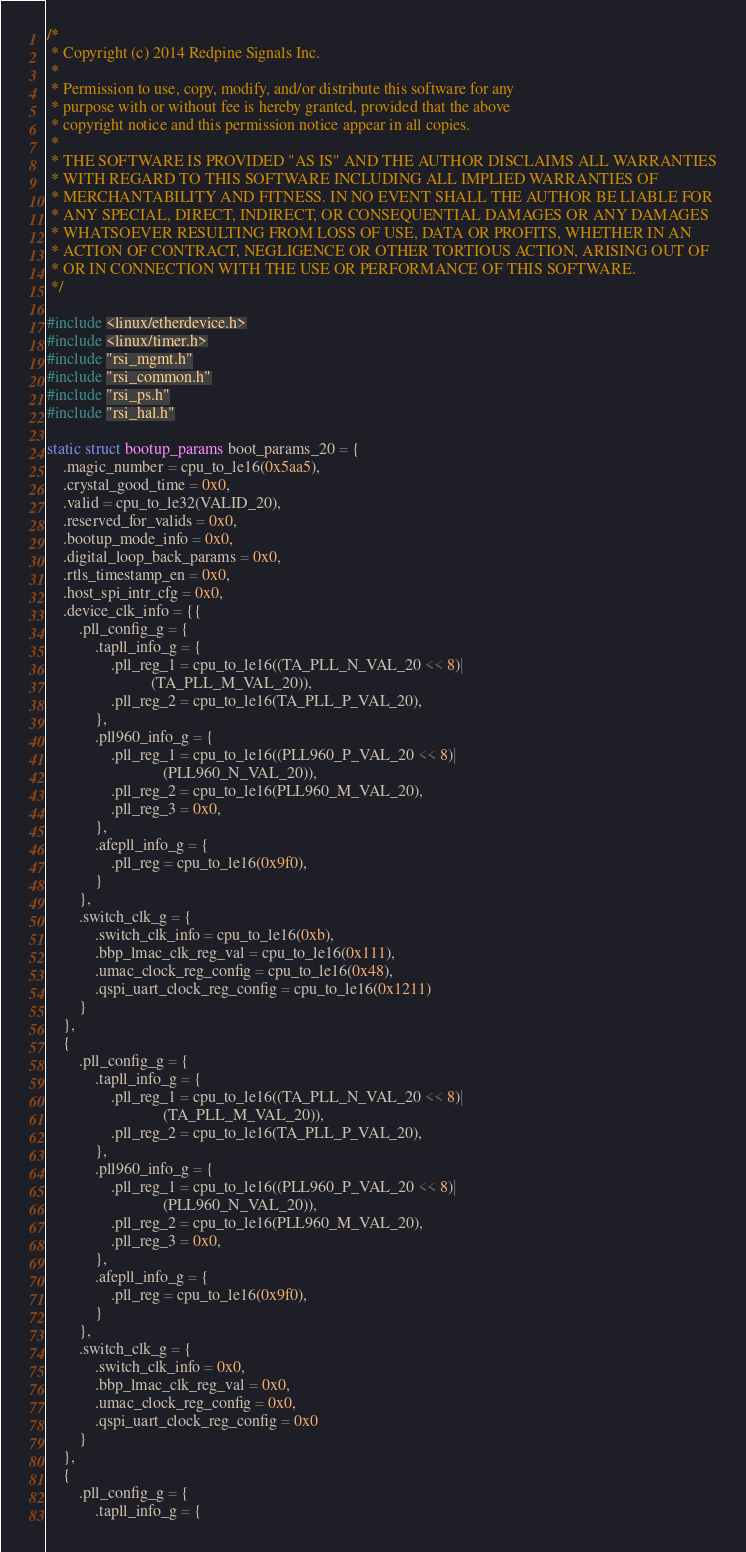Convert code to text. <code><loc_0><loc_0><loc_500><loc_500><_C_>/*
 * Copyright (c) 2014 Redpine Signals Inc.
 *
 * Permission to use, copy, modify, and/or distribute this software for any
 * purpose with or without fee is hereby granted, provided that the above
 * copyright notice and this permission notice appear in all copies.
 *
 * THE SOFTWARE IS PROVIDED "AS IS" AND THE AUTHOR DISCLAIMS ALL WARRANTIES
 * WITH REGARD TO THIS SOFTWARE INCLUDING ALL IMPLIED WARRANTIES OF
 * MERCHANTABILITY AND FITNESS. IN NO EVENT SHALL THE AUTHOR BE LIABLE FOR
 * ANY SPECIAL, DIRECT, INDIRECT, OR CONSEQUENTIAL DAMAGES OR ANY DAMAGES
 * WHATSOEVER RESULTING FROM LOSS OF USE, DATA OR PROFITS, WHETHER IN AN
 * ACTION OF CONTRACT, NEGLIGENCE OR OTHER TORTIOUS ACTION, ARISING OUT OF
 * OR IN CONNECTION WITH THE USE OR PERFORMANCE OF THIS SOFTWARE.
 */

#include <linux/etherdevice.h>
#include <linux/timer.h>
#include "rsi_mgmt.h"
#include "rsi_common.h"
#include "rsi_ps.h"
#include "rsi_hal.h"

static struct bootup_params boot_params_20 = {
	.magic_number = cpu_to_le16(0x5aa5),
	.crystal_good_time = 0x0,
	.valid = cpu_to_le32(VALID_20),
	.reserved_for_valids = 0x0,
	.bootup_mode_info = 0x0,
	.digital_loop_back_params = 0x0,
	.rtls_timestamp_en = 0x0,
	.host_spi_intr_cfg = 0x0,
	.device_clk_info = {{
		.pll_config_g = {
			.tapll_info_g = {
				.pll_reg_1 = cpu_to_le16((TA_PLL_N_VAL_20 << 8)|
					      (TA_PLL_M_VAL_20)),
				.pll_reg_2 = cpu_to_le16(TA_PLL_P_VAL_20),
			},
			.pll960_info_g = {
				.pll_reg_1 = cpu_to_le16((PLL960_P_VAL_20 << 8)|
							 (PLL960_N_VAL_20)),
				.pll_reg_2 = cpu_to_le16(PLL960_M_VAL_20),
				.pll_reg_3 = 0x0,
			},
			.afepll_info_g = {
				.pll_reg = cpu_to_le16(0x9f0),
			}
		},
		.switch_clk_g = {
			.switch_clk_info = cpu_to_le16(0xb),
			.bbp_lmac_clk_reg_val = cpu_to_le16(0x111),
			.umac_clock_reg_config = cpu_to_le16(0x48),
			.qspi_uart_clock_reg_config = cpu_to_le16(0x1211)
		}
	},
	{
		.pll_config_g = {
			.tapll_info_g = {
				.pll_reg_1 = cpu_to_le16((TA_PLL_N_VAL_20 << 8)|
							 (TA_PLL_M_VAL_20)),
				.pll_reg_2 = cpu_to_le16(TA_PLL_P_VAL_20),
			},
			.pll960_info_g = {
				.pll_reg_1 = cpu_to_le16((PLL960_P_VAL_20 << 8)|
							 (PLL960_N_VAL_20)),
				.pll_reg_2 = cpu_to_le16(PLL960_M_VAL_20),
				.pll_reg_3 = 0x0,
			},
			.afepll_info_g = {
				.pll_reg = cpu_to_le16(0x9f0),
			}
		},
		.switch_clk_g = {
			.switch_clk_info = 0x0,
			.bbp_lmac_clk_reg_val = 0x0,
			.umac_clock_reg_config = 0x0,
			.qspi_uart_clock_reg_config = 0x0
		}
	},
	{
		.pll_config_g = {
			.tapll_info_g = {</code> 